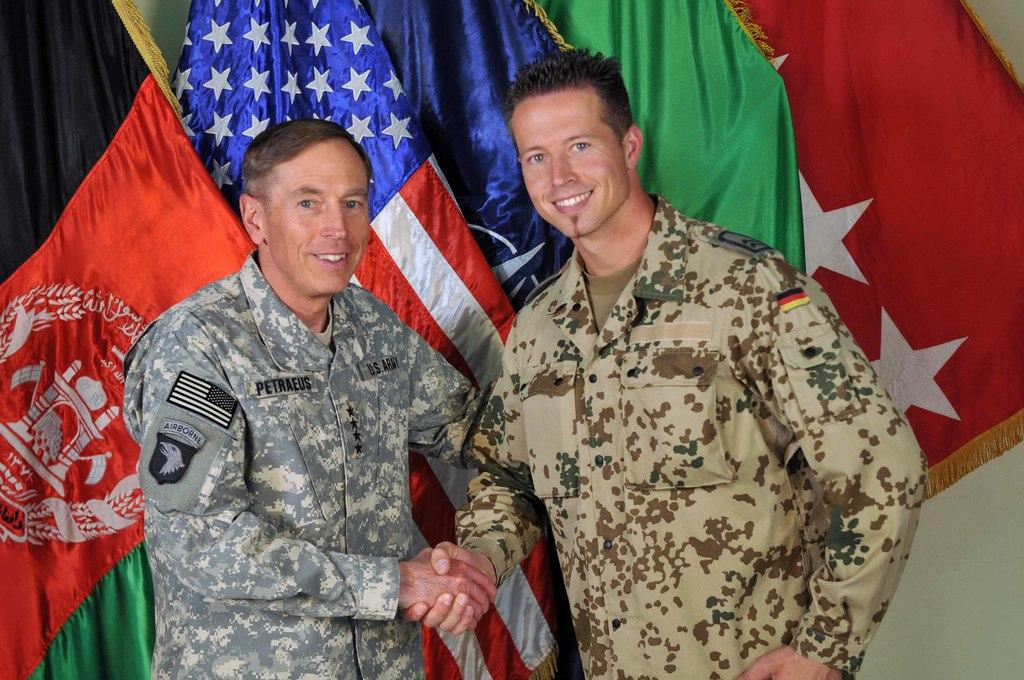What type of people are in the image? There are military soldiers in the image. Where are the soldiers positioned in the image? The soldiers are standing in the front. What are the soldiers doing in the image? The soldiers are shaking hands and smiling. What can be seen in the background of the image? There are flags visible in the background of the image. What type of needle is being used by the soldiers in the image? There is no needle present in the image; the soldiers are shaking hands and smiling. Can you tell me how many tomatoes are on the ground in the image? There are no tomatoes present in the image; it features military soldiers shaking hands and smiling. 